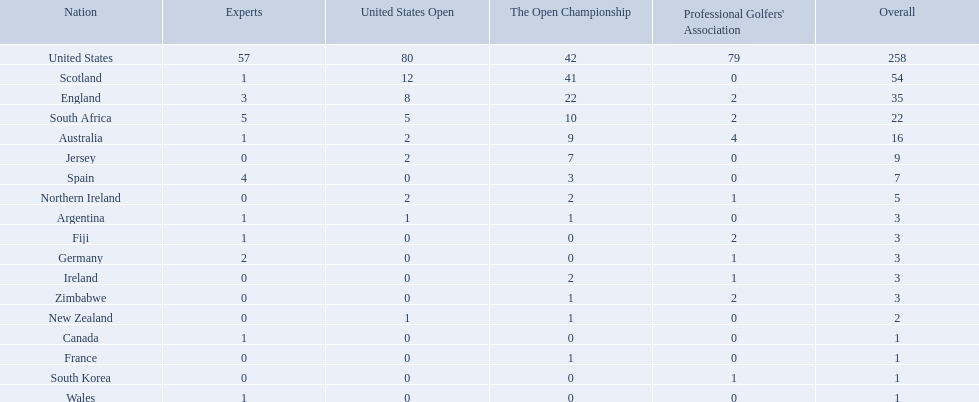What countries in the championship were from africa? South Africa, Zimbabwe. Which of these counteries had the least championship golfers Zimbabwe. 